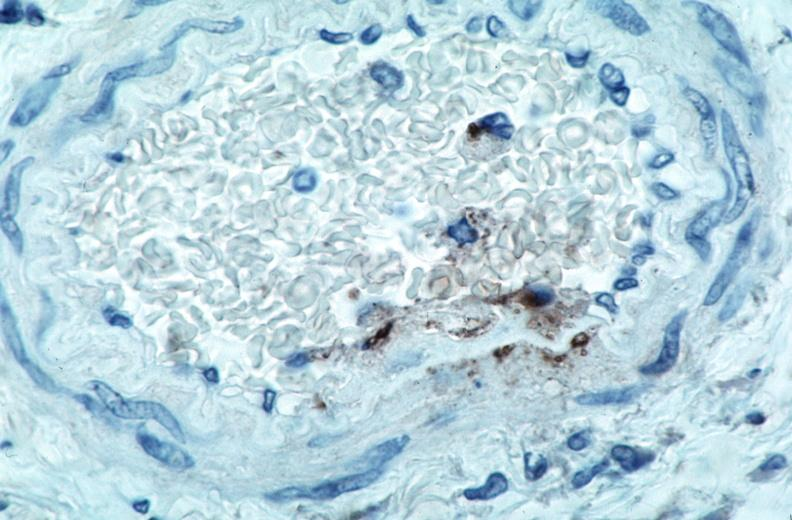does this image show vasculitis?
Answer the question using a single word or phrase. Yes 